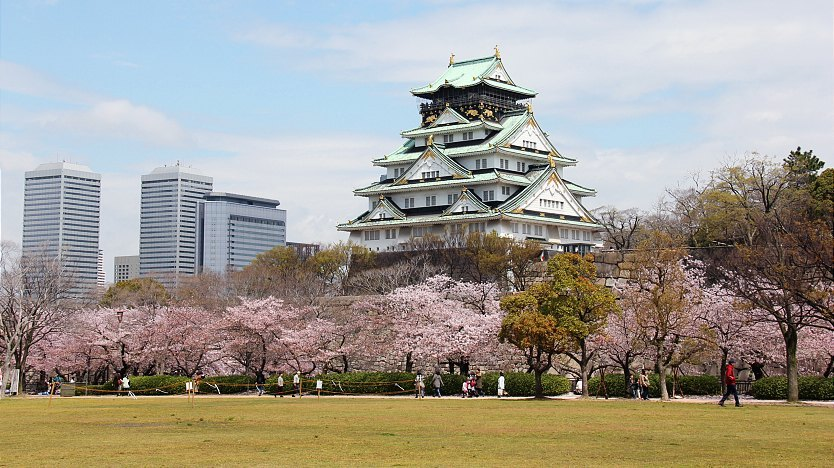Imagine if the Osaka Castle could speak, what stories might it tell us? If the Osaka Castle could speak, it would recount epic tales of sharegpt4v/samurai battles, the ambition of Toyotomi Hideyoshi, and the countless sieges it endured. It would share stories of resilience, as it was rebuilt after destruction from wars and fires. The castle would tell us about the peaceful times it witnessed, the cherry blossoms blooming year after year, and the whispers of visitors from around the world who marveled at its beauty and historical significance. 